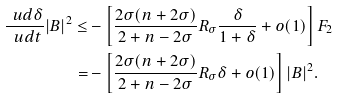Convert formula to latex. <formula><loc_0><loc_0><loc_500><loc_500>\frac { \ u d \delta } { \ u d t } | B | ^ { 2 } \leq & - \left [ \frac { 2 \sigma ( n + 2 \sigma ) } { 2 + n - 2 \sigma } R _ { \sigma } \frac { \delta } { 1 + \delta } + o ( 1 ) \right ] F _ { 2 } \\ = & - \left [ \frac { 2 \sigma ( n + 2 \sigma ) } { 2 + n - 2 \sigma } R _ { \sigma } \delta + o ( 1 ) \right ] | B | ^ { 2 } .</formula> 